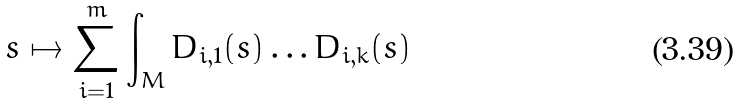Convert formula to latex. <formula><loc_0><loc_0><loc_500><loc_500>s \mapsto \sum _ { i = 1 } ^ { m } \int _ { M } D _ { i , 1 } ( s ) \dots D _ { i , k } ( s )</formula> 